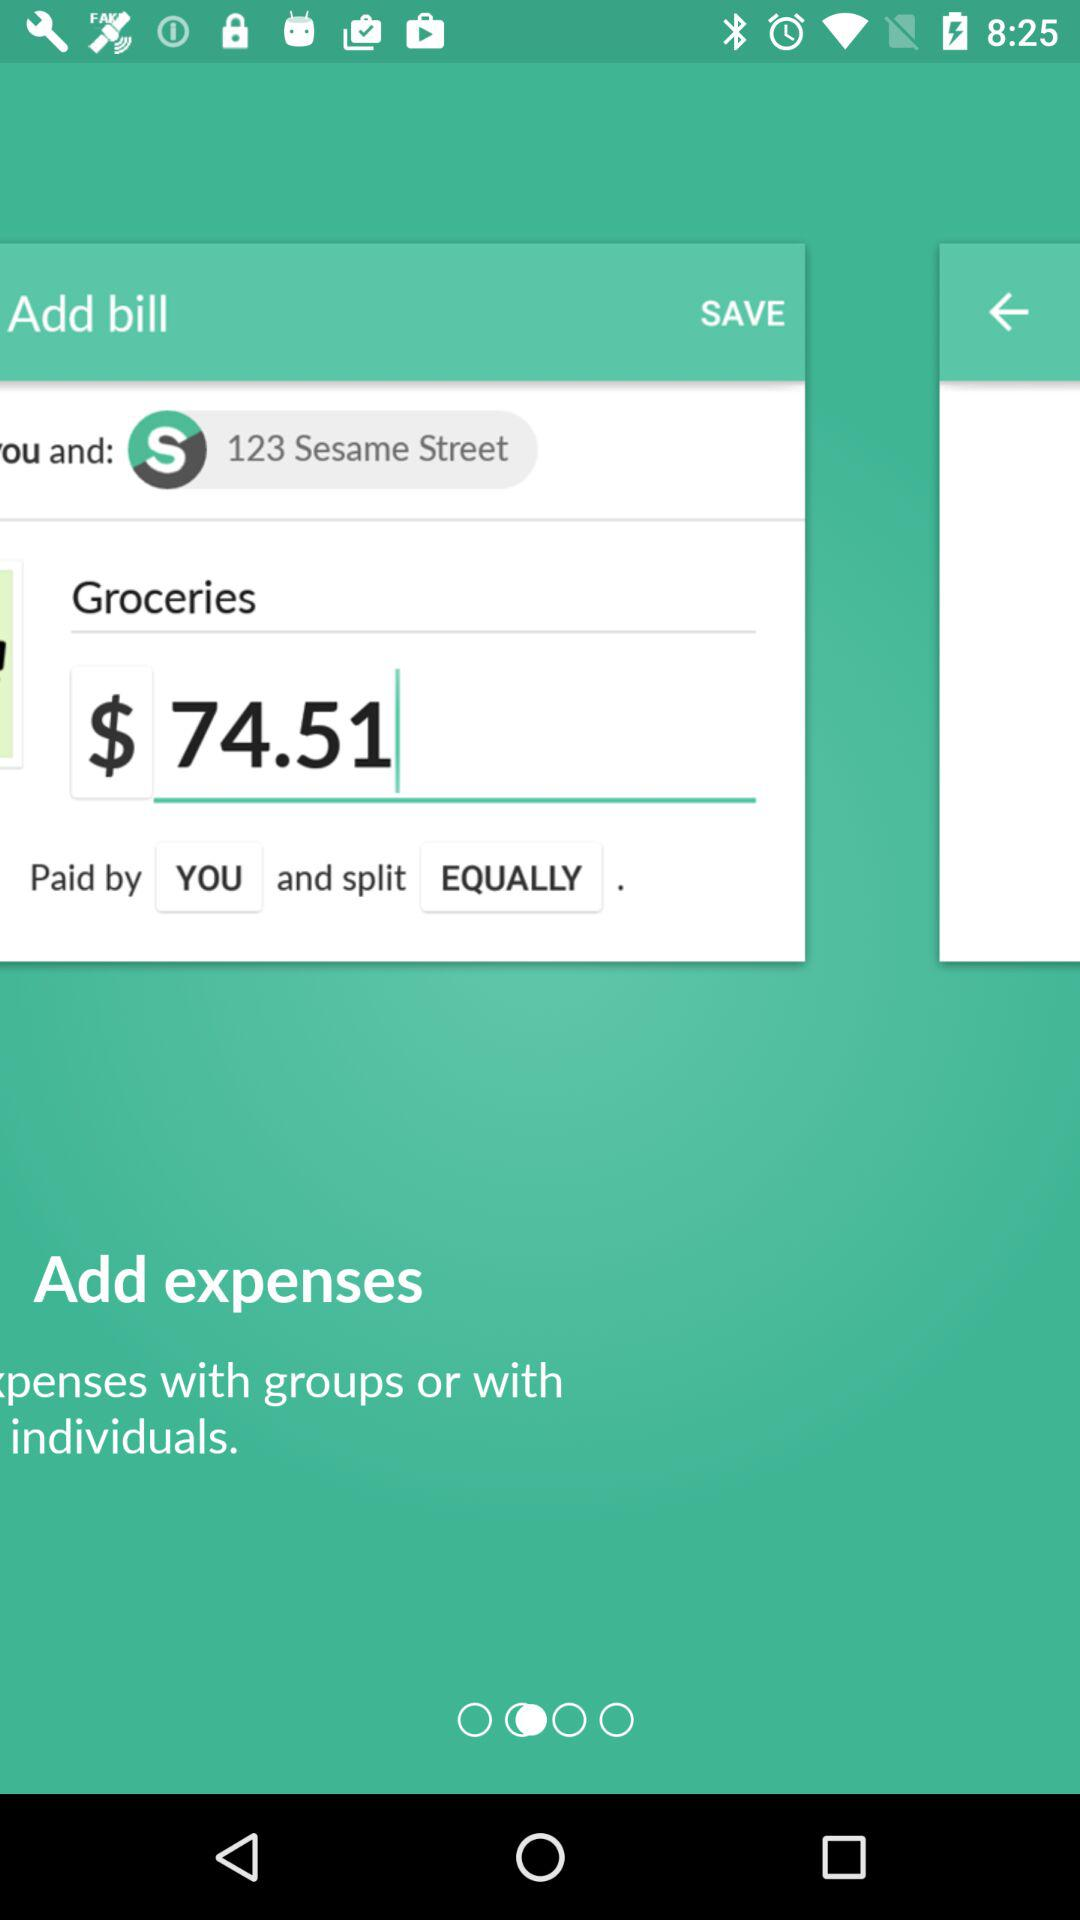How much does the bill total?
Answer the question using a single word or phrase. 74.51 